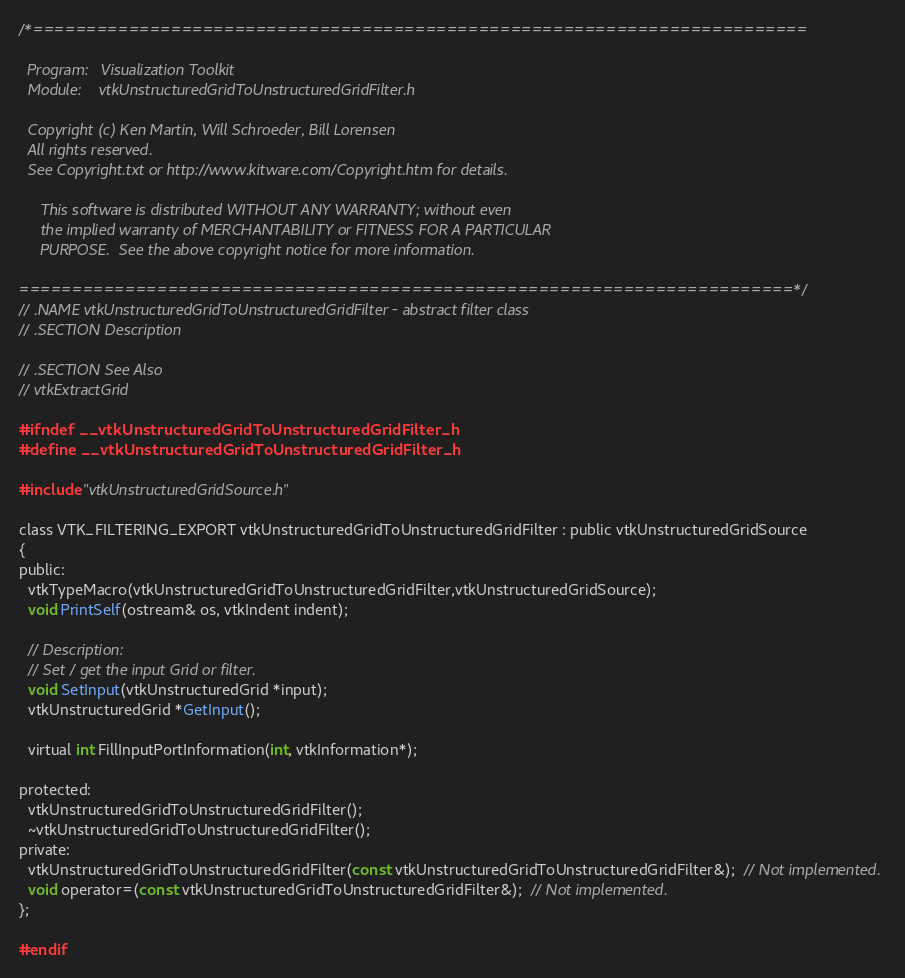<code> <loc_0><loc_0><loc_500><loc_500><_C_>/*=========================================================================

  Program:   Visualization Toolkit
  Module:    vtkUnstructuredGridToUnstructuredGridFilter.h

  Copyright (c) Ken Martin, Will Schroeder, Bill Lorensen
  All rights reserved.
  See Copyright.txt or http://www.kitware.com/Copyright.htm for details.

     This software is distributed WITHOUT ANY WARRANTY; without even
     the implied warranty of MERCHANTABILITY or FITNESS FOR A PARTICULAR
     PURPOSE.  See the above copyright notice for more information.

=========================================================================*/
// .NAME vtkUnstructuredGridToUnstructuredGridFilter - abstract filter class
// .SECTION Description

// .SECTION See Also
// vtkExtractGrid

#ifndef __vtkUnstructuredGridToUnstructuredGridFilter_h
#define __vtkUnstructuredGridToUnstructuredGridFilter_h

#include "vtkUnstructuredGridSource.h"

class VTK_FILTERING_EXPORT vtkUnstructuredGridToUnstructuredGridFilter : public vtkUnstructuredGridSource
{
public:
  vtkTypeMacro(vtkUnstructuredGridToUnstructuredGridFilter,vtkUnstructuredGridSource);
  void PrintSelf(ostream& os, vtkIndent indent);

  // Description:
  // Set / get the input Grid or filter.
  void SetInput(vtkUnstructuredGrid *input);
  vtkUnstructuredGrid *GetInput();

  virtual int FillInputPortInformation(int, vtkInformation*);

protected:
  vtkUnstructuredGridToUnstructuredGridFilter();
  ~vtkUnstructuredGridToUnstructuredGridFilter();
private:
  vtkUnstructuredGridToUnstructuredGridFilter(const vtkUnstructuredGridToUnstructuredGridFilter&);  // Not implemented.
  void operator=(const vtkUnstructuredGridToUnstructuredGridFilter&);  // Not implemented.
};

#endif


</code> 